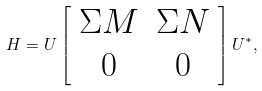Convert formula to latex. <formula><loc_0><loc_0><loc_500><loc_500>H = U \left [ \begin{array} { c c } \Sigma M & \Sigma N \\ 0 & 0 \\ \end{array} \right ] U ^ { * } ,</formula> 